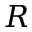Convert formula to latex. <formula><loc_0><loc_0><loc_500><loc_500>R</formula> 